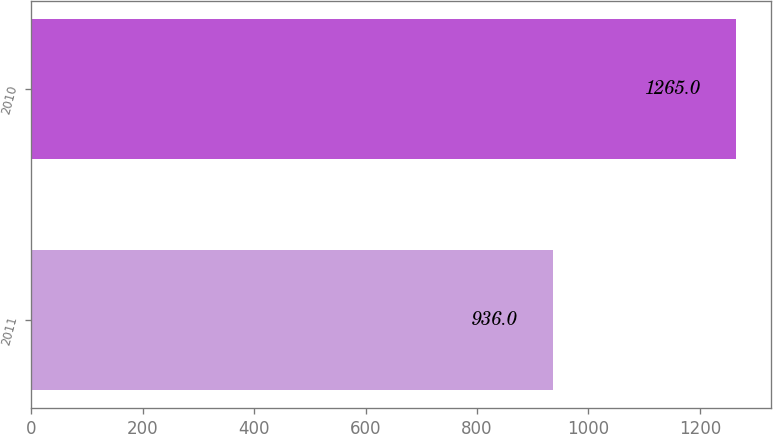<chart> <loc_0><loc_0><loc_500><loc_500><bar_chart><fcel>2011<fcel>2010<nl><fcel>936<fcel>1265<nl></chart> 